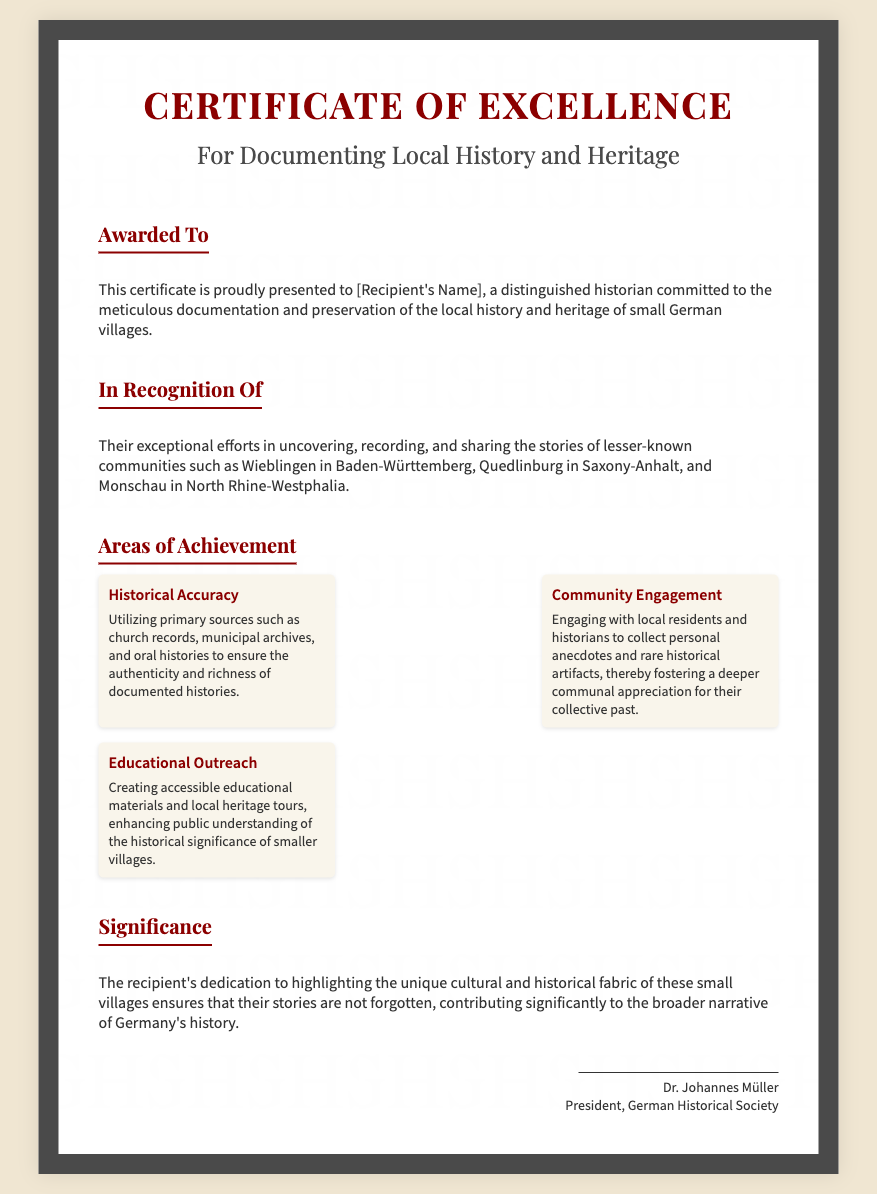What is the title of the certificate? The certificate is titled "Certificate of Excellence."
Answer: Certificate of Excellence Who is the certificate awarded to? The certificate is awarded to "[Recipient's Name]."
Answer: [Recipient's Name] Name one of the communities mentioned in the document. The document mentions Wieblingen, Quedlinburg, and Monschau as communities.
Answer: Wieblingen What is one area of achievement listed in the document? The document lists "Historical Accuracy," "Community Engagement," and "Educational Outreach" as areas of achievement.
Answer: Historical Accuracy Who signed the certificate? The certificate is signed by Dr. Johannes Müller.
Answer: Dr. Johannes Müller What organization does the signer represent? The signer represents the "German Historical Society."
Answer: German Historical Society What is highlighted as a significance of the recipient's work? The recipient's work ensures that the stories of small villages are not forgotten, contributing to a broader narrative of Germany’s history.
Answer: Unique cultural and historical fabric What font is used for the headings? The document uses "Playfair Display" for the headings.
Answer: Playfair Display What color is the border of the certificate? The border of the certificate is colored dark gray, specifically #4a4a4a.
Answer: #4a4a4a 